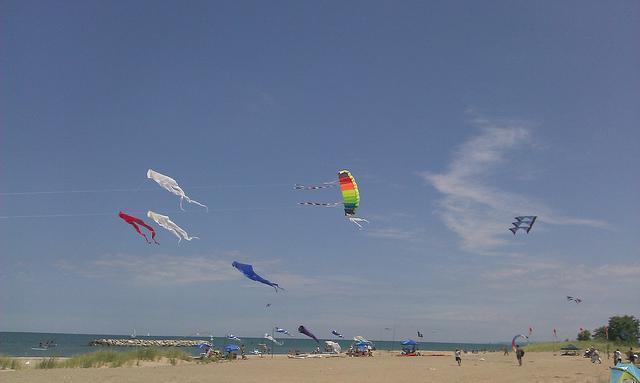Who uses the item in the sky the most?
Choose the correct response, then elucidate: 'Answer: answer
Rationale: rationale.'
Options: Kids, police officers, army sergeants, old men. Answer: kids.
Rationale: The kites in the sky are usually fun toys for kids to play with at the beach. 